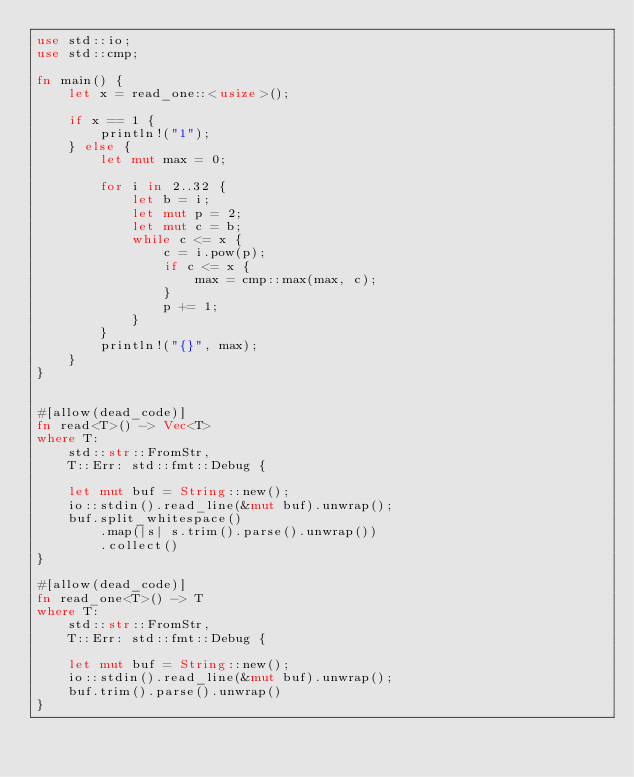<code> <loc_0><loc_0><loc_500><loc_500><_Rust_>use std::io;
use std::cmp;

fn main() {
    let x = read_one::<usize>();

    if x == 1 {
        println!("1");
    } else {
        let mut max = 0;

        for i in 2..32 {
            let b = i;
            let mut p = 2;
            let mut c = b;
            while c <= x {
                c = i.pow(p);
                if c <= x {
                    max = cmp::max(max, c);
                }
                p += 1;
            }
        }
        println!("{}", max);
    }
}


#[allow(dead_code)]
fn read<T>() -> Vec<T>
where T:
    std::str::FromStr,
    T::Err: std::fmt::Debug {

    let mut buf = String::new();
    io::stdin().read_line(&mut buf).unwrap();
    buf.split_whitespace()
        .map(|s| s.trim().parse().unwrap())
        .collect()
}

#[allow(dead_code)]
fn read_one<T>() -> T
where T:
    std::str::FromStr,
    T::Err: std::fmt::Debug {

    let mut buf = String::new();
    io::stdin().read_line(&mut buf).unwrap();
    buf.trim().parse().unwrap()
}</code> 